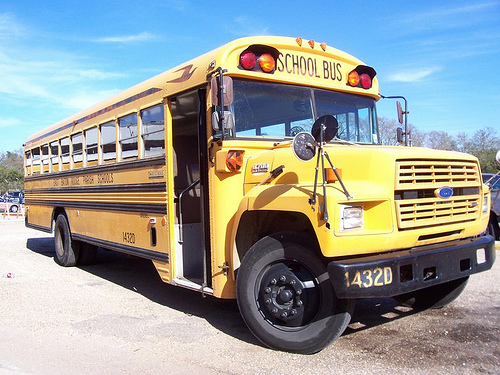Can you describe the vehicle in the image? The vehicle is a traditional yellow school bus, prevalent in North America for student transportation. It features a prominent front hood with the words 'SCHOOL BUS' written above the windshield. The bus number is 1320, and the plate number is 432D. The bus is designed with safety in mind, indicated by the bold yellow color, large mirrors for driver visibility, flashing lights, and the extendable stop sign on the left side. 